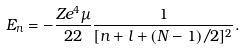<formula> <loc_0><loc_0><loc_500><loc_500>E _ { n } = - \frac { Z e ^ { 4 } \mu } { 2 { 2 } } \frac { 1 } { [ n + l + ( N - 1 ) / 2 ] ^ { 2 } } .</formula> 